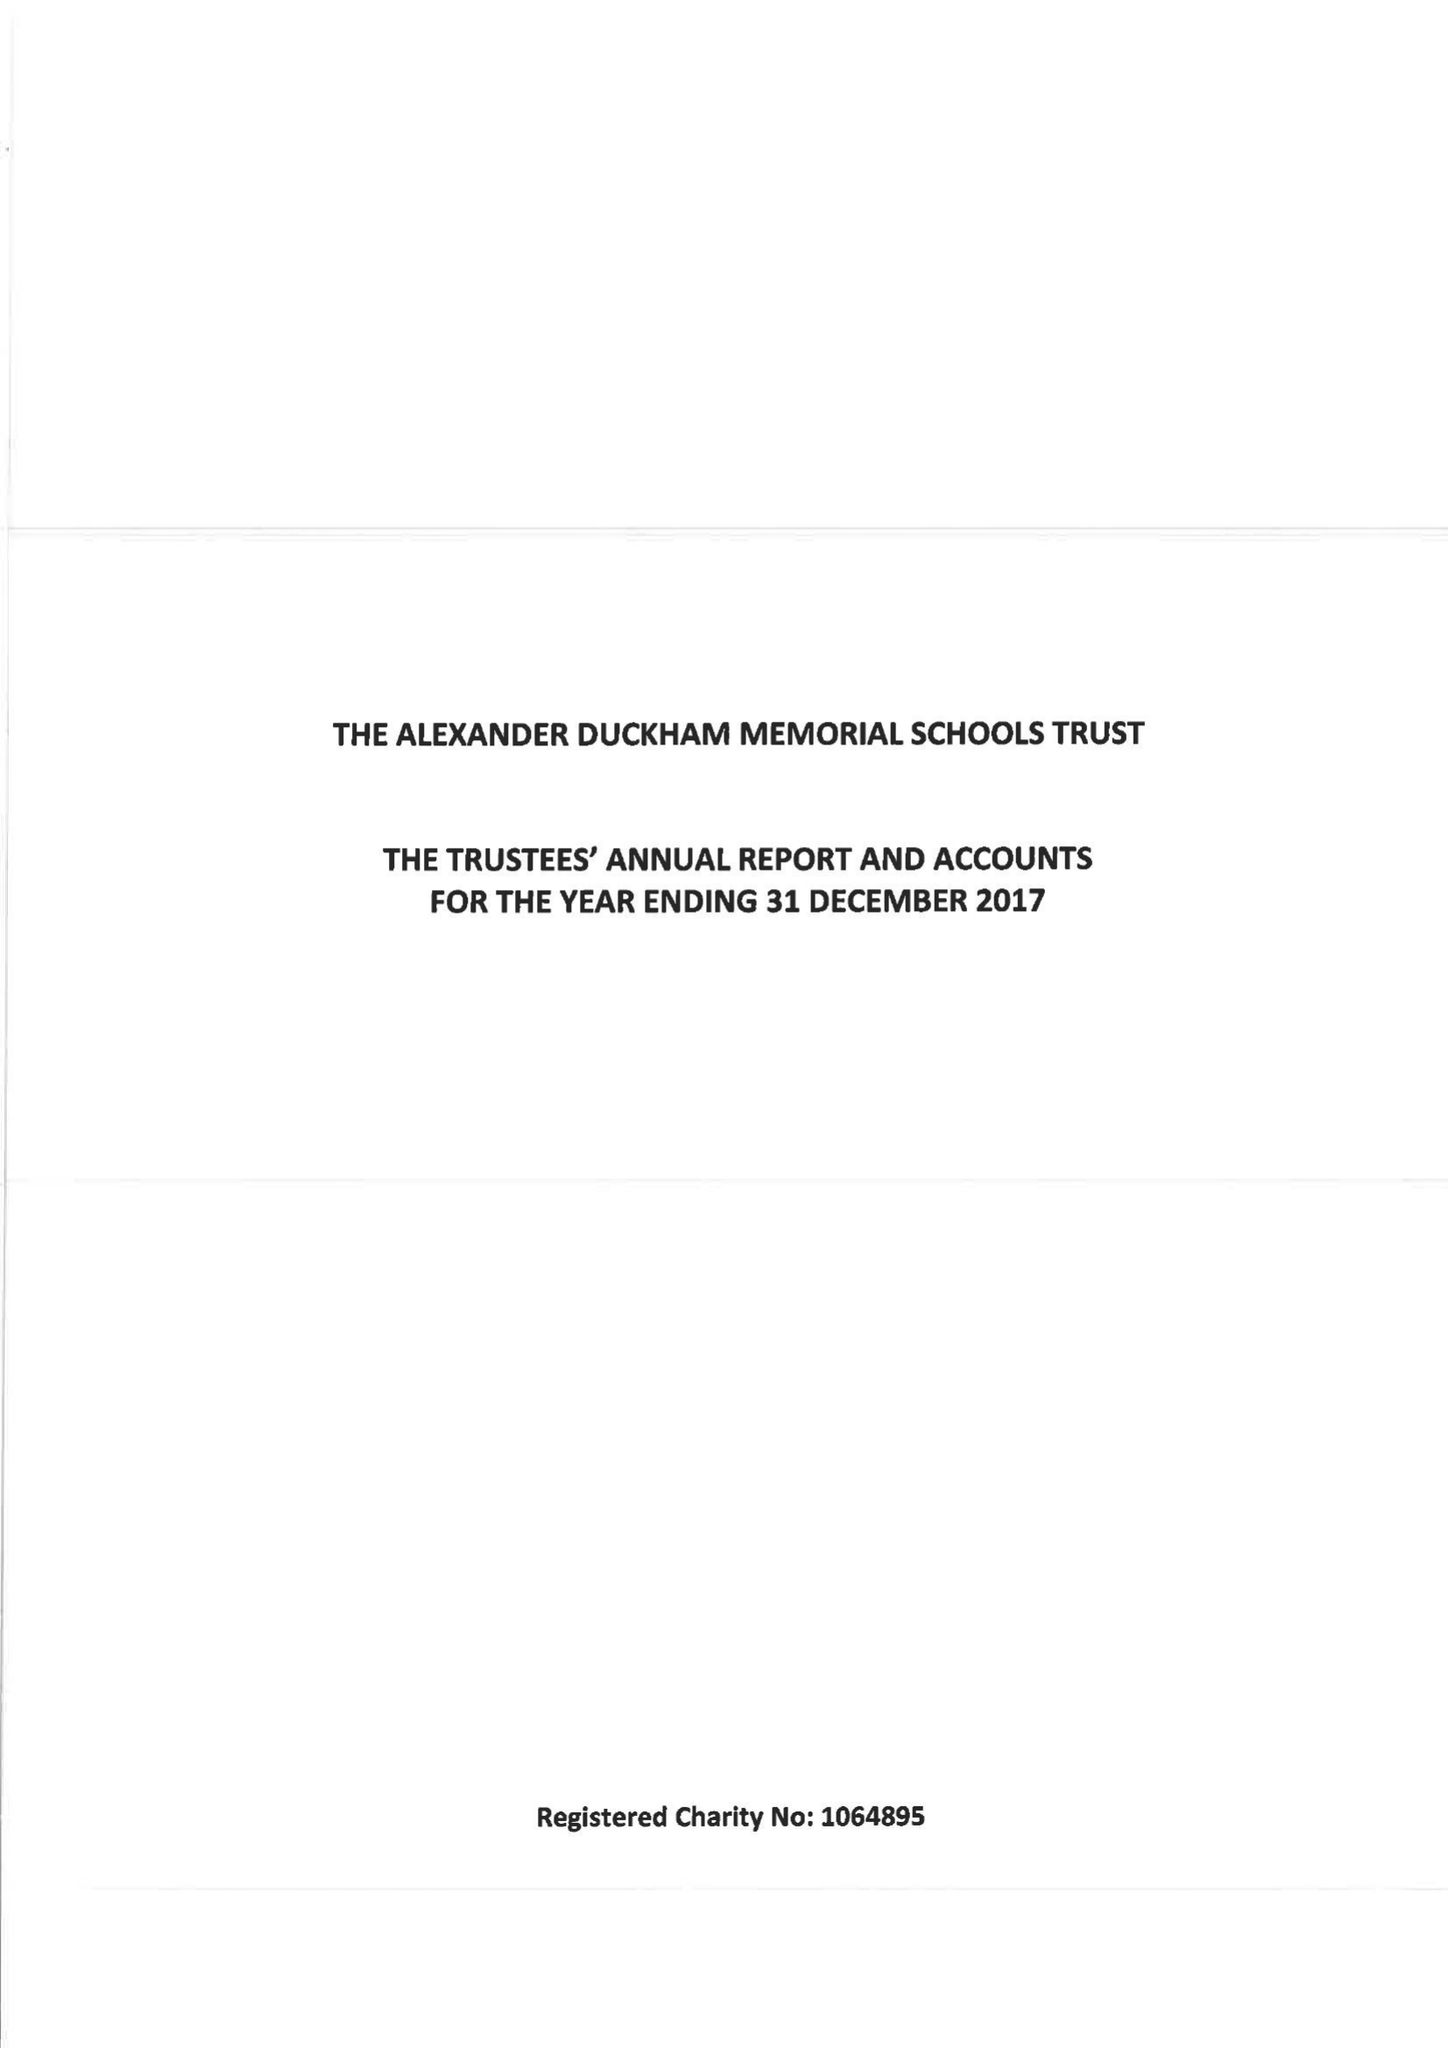What is the value for the charity_number?
Answer the question using a single word or phrase. 1064895 